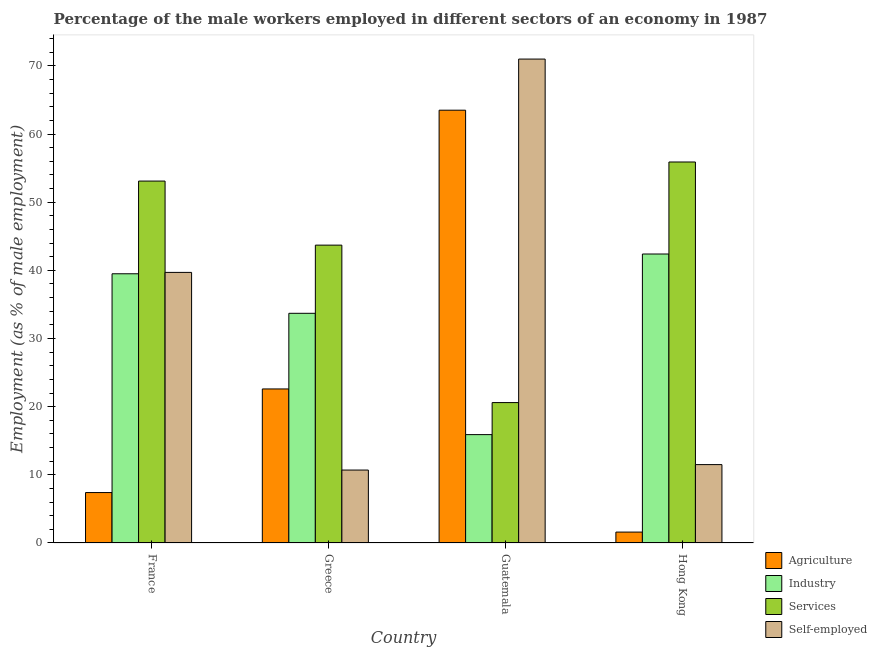How many different coloured bars are there?
Offer a very short reply. 4. Are the number of bars per tick equal to the number of legend labels?
Your answer should be compact. Yes. Are the number of bars on each tick of the X-axis equal?
Provide a short and direct response. Yes. How many bars are there on the 1st tick from the left?
Offer a very short reply. 4. What is the label of the 3rd group of bars from the left?
Offer a very short reply. Guatemala. What is the percentage of male workers in services in France?
Your response must be concise. 53.1. Across all countries, what is the maximum percentage of male workers in agriculture?
Your answer should be very brief. 63.5. Across all countries, what is the minimum percentage of self employed male workers?
Offer a very short reply. 10.7. In which country was the percentage of male workers in industry maximum?
Your answer should be compact. Hong Kong. In which country was the percentage of self employed male workers minimum?
Keep it short and to the point. Greece. What is the total percentage of male workers in industry in the graph?
Offer a very short reply. 131.5. What is the difference between the percentage of male workers in services in Guatemala and that in Hong Kong?
Offer a terse response. -35.3. What is the difference between the percentage of male workers in services in France and the percentage of male workers in industry in Guatemala?
Offer a very short reply. 37.2. What is the average percentage of male workers in agriculture per country?
Offer a very short reply. 23.78. What is the difference between the percentage of male workers in industry and percentage of male workers in services in Greece?
Provide a short and direct response. -10. In how many countries, is the percentage of male workers in industry greater than 30 %?
Your answer should be very brief. 3. What is the ratio of the percentage of male workers in services in Greece to that in Hong Kong?
Provide a succinct answer. 0.78. Is the difference between the percentage of male workers in agriculture in Greece and Guatemala greater than the difference between the percentage of male workers in industry in Greece and Guatemala?
Provide a short and direct response. No. What is the difference between the highest and the second highest percentage of male workers in industry?
Offer a terse response. 2.9. What is the difference between the highest and the lowest percentage of male workers in industry?
Provide a succinct answer. 26.5. Is it the case that in every country, the sum of the percentage of male workers in industry and percentage of male workers in services is greater than the sum of percentage of self employed male workers and percentage of male workers in agriculture?
Your response must be concise. No. What does the 1st bar from the left in Hong Kong represents?
Offer a very short reply. Agriculture. What does the 4th bar from the right in France represents?
Your answer should be compact. Agriculture. Is it the case that in every country, the sum of the percentage of male workers in agriculture and percentage of male workers in industry is greater than the percentage of male workers in services?
Your answer should be very brief. No. Are all the bars in the graph horizontal?
Provide a succinct answer. No. How many countries are there in the graph?
Your answer should be compact. 4. What is the difference between two consecutive major ticks on the Y-axis?
Your response must be concise. 10. Does the graph contain any zero values?
Give a very brief answer. No. How many legend labels are there?
Provide a short and direct response. 4. What is the title of the graph?
Offer a terse response. Percentage of the male workers employed in different sectors of an economy in 1987. Does "Denmark" appear as one of the legend labels in the graph?
Your answer should be compact. No. What is the label or title of the X-axis?
Your response must be concise. Country. What is the label or title of the Y-axis?
Keep it short and to the point. Employment (as % of male employment). What is the Employment (as % of male employment) in Agriculture in France?
Offer a very short reply. 7.4. What is the Employment (as % of male employment) in Industry in France?
Make the answer very short. 39.5. What is the Employment (as % of male employment) in Services in France?
Offer a very short reply. 53.1. What is the Employment (as % of male employment) of Self-employed in France?
Keep it short and to the point. 39.7. What is the Employment (as % of male employment) in Agriculture in Greece?
Keep it short and to the point. 22.6. What is the Employment (as % of male employment) in Industry in Greece?
Your answer should be very brief. 33.7. What is the Employment (as % of male employment) of Services in Greece?
Ensure brevity in your answer.  43.7. What is the Employment (as % of male employment) in Self-employed in Greece?
Provide a succinct answer. 10.7. What is the Employment (as % of male employment) of Agriculture in Guatemala?
Give a very brief answer. 63.5. What is the Employment (as % of male employment) in Industry in Guatemala?
Provide a short and direct response. 15.9. What is the Employment (as % of male employment) of Services in Guatemala?
Your answer should be compact. 20.6. What is the Employment (as % of male employment) of Self-employed in Guatemala?
Give a very brief answer. 71. What is the Employment (as % of male employment) of Agriculture in Hong Kong?
Offer a terse response. 1.6. What is the Employment (as % of male employment) in Industry in Hong Kong?
Provide a succinct answer. 42.4. What is the Employment (as % of male employment) in Services in Hong Kong?
Keep it short and to the point. 55.9. Across all countries, what is the maximum Employment (as % of male employment) of Agriculture?
Provide a succinct answer. 63.5. Across all countries, what is the maximum Employment (as % of male employment) of Industry?
Your response must be concise. 42.4. Across all countries, what is the maximum Employment (as % of male employment) of Services?
Provide a succinct answer. 55.9. Across all countries, what is the maximum Employment (as % of male employment) of Self-employed?
Your answer should be very brief. 71. Across all countries, what is the minimum Employment (as % of male employment) in Agriculture?
Your answer should be very brief. 1.6. Across all countries, what is the minimum Employment (as % of male employment) in Industry?
Your answer should be very brief. 15.9. Across all countries, what is the minimum Employment (as % of male employment) in Services?
Your response must be concise. 20.6. Across all countries, what is the minimum Employment (as % of male employment) in Self-employed?
Keep it short and to the point. 10.7. What is the total Employment (as % of male employment) in Agriculture in the graph?
Provide a short and direct response. 95.1. What is the total Employment (as % of male employment) in Industry in the graph?
Offer a terse response. 131.5. What is the total Employment (as % of male employment) of Services in the graph?
Give a very brief answer. 173.3. What is the total Employment (as % of male employment) in Self-employed in the graph?
Keep it short and to the point. 132.9. What is the difference between the Employment (as % of male employment) of Agriculture in France and that in Greece?
Keep it short and to the point. -15.2. What is the difference between the Employment (as % of male employment) in Industry in France and that in Greece?
Provide a short and direct response. 5.8. What is the difference between the Employment (as % of male employment) in Services in France and that in Greece?
Offer a terse response. 9.4. What is the difference between the Employment (as % of male employment) of Agriculture in France and that in Guatemala?
Your answer should be very brief. -56.1. What is the difference between the Employment (as % of male employment) in Industry in France and that in Guatemala?
Provide a succinct answer. 23.6. What is the difference between the Employment (as % of male employment) of Services in France and that in Guatemala?
Keep it short and to the point. 32.5. What is the difference between the Employment (as % of male employment) in Self-employed in France and that in Guatemala?
Provide a succinct answer. -31.3. What is the difference between the Employment (as % of male employment) of Industry in France and that in Hong Kong?
Give a very brief answer. -2.9. What is the difference between the Employment (as % of male employment) in Self-employed in France and that in Hong Kong?
Give a very brief answer. 28.2. What is the difference between the Employment (as % of male employment) in Agriculture in Greece and that in Guatemala?
Provide a succinct answer. -40.9. What is the difference between the Employment (as % of male employment) of Industry in Greece and that in Guatemala?
Your answer should be compact. 17.8. What is the difference between the Employment (as % of male employment) in Services in Greece and that in Guatemala?
Your response must be concise. 23.1. What is the difference between the Employment (as % of male employment) in Self-employed in Greece and that in Guatemala?
Ensure brevity in your answer.  -60.3. What is the difference between the Employment (as % of male employment) of Agriculture in Greece and that in Hong Kong?
Provide a succinct answer. 21. What is the difference between the Employment (as % of male employment) of Services in Greece and that in Hong Kong?
Provide a succinct answer. -12.2. What is the difference between the Employment (as % of male employment) in Agriculture in Guatemala and that in Hong Kong?
Offer a terse response. 61.9. What is the difference between the Employment (as % of male employment) of Industry in Guatemala and that in Hong Kong?
Offer a very short reply. -26.5. What is the difference between the Employment (as % of male employment) of Services in Guatemala and that in Hong Kong?
Your response must be concise. -35.3. What is the difference between the Employment (as % of male employment) of Self-employed in Guatemala and that in Hong Kong?
Make the answer very short. 59.5. What is the difference between the Employment (as % of male employment) of Agriculture in France and the Employment (as % of male employment) of Industry in Greece?
Make the answer very short. -26.3. What is the difference between the Employment (as % of male employment) of Agriculture in France and the Employment (as % of male employment) of Services in Greece?
Make the answer very short. -36.3. What is the difference between the Employment (as % of male employment) of Agriculture in France and the Employment (as % of male employment) of Self-employed in Greece?
Give a very brief answer. -3.3. What is the difference between the Employment (as % of male employment) in Industry in France and the Employment (as % of male employment) in Services in Greece?
Offer a very short reply. -4.2. What is the difference between the Employment (as % of male employment) in Industry in France and the Employment (as % of male employment) in Self-employed in Greece?
Your response must be concise. 28.8. What is the difference between the Employment (as % of male employment) of Services in France and the Employment (as % of male employment) of Self-employed in Greece?
Provide a succinct answer. 42.4. What is the difference between the Employment (as % of male employment) of Agriculture in France and the Employment (as % of male employment) of Industry in Guatemala?
Your response must be concise. -8.5. What is the difference between the Employment (as % of male employment) in Agriculture in France and the Employment (as % of male employment) in Services in Guatemala?
Your answer should be very brief. -13.2. What is the difference between the Employment (as % of male employment) of Agriculture in France and the Employment (as % of male employment) of Self-employed in Guatemala?
Offer a terse response. -63.6. What is the difference between the Employment (as % of male employment) in Industry in France and the Employment (as % of male employment) in Services in Guatemala?
Offer a very short reply. 18.9. What is the difference between the Employment (as % of male employment) in Industry in France and the Employment (as % of male employment) in Self-employed in Guatemala?
Offer a very short reply. -31.5. What is the difference between the Employment (as % of male employment) in Services in France and the Employment (as % of male employment) in Self-employed in Guatemala?
Ensure brevity in your answer.  -17.9. What is the difference between the Employment (as % of male employment) in Agriculture in France and the Employment (as % of male employment) in Industry in Hong Kong?
Provide a succinct answer. -35. What is the difference between the Employment (as % of male employment) of Agriculture in France and the Employment (as % of male employment) of Services in Hong Kong?
Provide a succinct answer. -48.5. What is the difference between the Employment (as % of male employment) of Industry in France and the Employment (as % of male employment) of Services in Hong Kong?
Your response must be concise. -16.4. What is the difference between the Employment (as % of male employment) in Services in France and the Employment (as % of male employment) in Self-employed in Hong Kong?
Make the answer very short. 41.6. What is the difference between the Employment (as % of male employment) of Agriculture in Greece and the Employment (as % of male employment) of Industry in Guatemala?
Your response must be concise. 6.7. What is the difference between the Employment (as % of male employment) in Agriculture in Greece and the Employment (as % of male employment) in Self-employed in Guatemala?
Make the answer very short. -48.4. What is the difference between the Employment (as % of male employment) in Industry in Greece and the Employment (as % of male employment) in Services in Guatemala?
Your answer should be compact. 13.1. What is the difference between the Employment (as % of male employment) in Industry in Greece and the Employment (as % of male employment) in Self-employed in Guatemala?
Provide a short and direct response. -37.3. What is the difference between the Employment (as % of male employment) of Services in Greece and the Employment (as % of male employment) of Self-employed in Guatemala?
Ensure brevity in your answer.  -27.3. What is the difference between the Employment (as % of male employment) of Agriculture in Greece and the Employment (as % of male employment) of Industry in Hong Kong?
Your response must be concise. -19.8. What is the difference between the Employment (as % of male employment) in Agriculture in Greece and the Employment (as % of male employment) in Services in Hong Kong?
Your answer should be compact. -33.3. What is the difference between the Employment (as % of male employment) of Industry in Greece and the Employment (as % of male employment) of Services in Hong Kong?
Ensure brevity in your answer.  -22.2. What is the difference between the Employment (as % of male employment) in Services in Greece and the Employment (as % of male employment) in Self-employed in Hong Kong?
Your response must be concise. 32.2. What is the difference between the Employment (as % of male employment) of Agriculture in Guatemala and the Employment (as % of male employment) of Industry in Hong Kong?
Provide a short and direct response. 21.1. What is the difference between the Employment (as % of male employment) of Services in Guatemala and the Employment (as % of male employment) of Self-employed in Hong Kong?
Your response must be concise. 9.1. What is the average Employment (as % of male employment) in Agriculture per country?
Make the answer very short. 23.77. What is the average Employment (as % of male employment) of Industry per country?
Keep it short and to the point. 32.88. What is the average Employment (as % of male employment) of Services per country?
Your answer should be very brief. 43.33. What is the average Employment (as % of male employment) in Self-employed per country?
Provide a short and direct response. 33.23. What is the difference between the Employment (as % of male employment) of Agriculture and Employment (as % of male employment) of Industry in France?
Your answer should be compact. -32.1. What is the difference between the Employment (as % of male employment) in Agriculture and Employment (as % of male employment) in Services in France?
Offer a very short reply. -45.7. What is the difference between the Employment (as % of male employment) of Agriculture and Employment (as % of male employment) of Self-employed in France?
Provide a succinct answer. -32.3. What is the difference between the Employment (as % of male employment) in Industry and Employment (as % of male employment) in Services in France?
Your answer should be very brief. -13.6. What is the difference between the Employment (as % of male employment) in Services and Employment (as % of male employment) in Self-employed in France?
Give a very brief answer. 13.4. What is the difference between the Employment (as % of male employment) of Agriculture and Employment (as % of male employment) of Services in Greece?
Your answer should be compact. -21.1. What is the difference between the Employment (as % of male employment) of Agriculture and Employment (as % of male employment) of Self-employed in Greece?
Offer a terse response. 11.9. What is the difference between the Employment (as % of male employment) of Services and Employment (as % of male employment) of Self-employed in Greece?
Provide a succinct answer. 33. What is the difference between the Employment (as % of male employment) of Agriculture and Employment (as % of male employment) of Industry in Guatemala?
Your answer should be very brief. 47.6. What is the difference between the Employment (as % of male employment) of Agriculture and Employment (as % of male employment) of Services in Guatemala?
Ensure brevity in your answer.  42.9. What is the difference between the Employment (as % of male employment) of Agriculture and Employment (as % of male employment) of Self-employed in Guatemala?
Provide a short and direct response. -7.5. What is the difference between the Employment (as % of male employment) in Industry and Employment (as % of male employment) in Self-employed in Guatemala?
Provide a short and direct response. -55.1. What is the difference between the Employment (as % of male employment) of Services and Employment (as % of male employment) of Self-employed in Guatemala?
Offer a terse response. -50.4. What is the difference between the Employment (as % of male employment) in Agriculture and Employment (as % of male employment) in Industry in Hong Kong?
Offer a very short reply. -40.8. What is the difference between the Employment (as % of male employment) in Agriculture and Employment (as % of male employment) in Services in Hong Kong?
Offer a very short reply. -54.3. What is the difference between the Employment (as % of male employment) in Industry and Employment (as % of male employment) in Services in Hong Kong?
Offer a very short reply. -13.5. What is the difference between the Employment (as % of male employment) of Industry and Employment (as % of male employment) of Self-employed in Hong Kong?
Ensure brevity in your answer.  30.9. What is the difference between the Employment (as % of male employment) in Services and Employment (as % of male employment) in Self-employed in Hong Kong?
Give a very brief answer. 44.4. What is the ratio of the Employment (as % of male employment) of Agriculture in France to that in Greece?
Provide a short and direct response. 0.33. What is the ratio of the Employment (as % of male employment) of Industry in France to that in Greece?
Give a very brief answer. 1.17. What is the ratio of the Employment (as % of male employment) in Services in France to that in Greece?
Offer a terse response. 1.22. What is the ratio of the Employment (as % of male employment) of Self-employed in France to that in Greece?
Offer a terse response. 3.71. What is the ratio of the Employment (as % of male employment) in Agriculture in France to that in Guatemala?
Provide a short and direct response. 0.12. What is the ratio of the Employment (as % of male employment) in Industry in France to that in Guatemala?
Your response must be concise. 2.48. What is the ratio of the Employment (as % of male employment) in Services in France to that in Guatemala?
Offer a terse response. 2.58. What is the ratio of the Employment (as % of male employment) of Self-employed in France to that in Guatemala?
Give a very brief answer. 0.56. What is the ratio of the Employment (as % of male employment) of Agriculture in France to that in Hong Kong?
Ensure brevity in your answer.  4.62. What is the ratio of the Employment (as % of male employment) of Industry in France to that in Hong Kong?
Your answer should be very brief. 0.93. What is the ratio of the Employment (as % of male employment) in Services in France to that in Hong Kong?
Offer a very short reply. 0.95. What is the ratio of the Employment (as % of male employment) of Self-employed in France to that in Hong Kong?
Your response must be concise. 3.45. What is the ratio of the Employment (as % of male employment) in Agriculture in Greece to that in Guatemala?
Your response must be concise. 0.36. What is the ratio of the Employment (as % of male employment) of Industry in Greece to that in Guatemala?
Your answer should be very brief. 2.12. What is the ratio of the Employment (as % of male employment) in Services in Greece to that in Guatemala?
Offer a terse response. 2.12. What is the ratio of the Employment (as % of male employment) in Self-employed in Greece to that in Guatemala?
Give a very brief answer. 0.15. What is the ratio of the Employment (as % of male employment) of Agriculture in Greece to that in Hong Kong?
Your response must be concise. 14.12. What is the ratio of the Employment (as % of male employment) in Industry in Greece to that in Hong Kong?
Your response must be concise. 0.79. What is the ratio of the Employment (as % of male employment) of Services in Greece to that in Hong Kong?
Provide a short and direct response. 0.78. What is the ratio of the Employment (as % of male employment) in Self-employed in Greece to that in Hong Kong?
Keep it short and to the point. 0.93. What is the ratio of the Employment (as % of male employment) of Agriculture in Guatemala to that in Hong Kong?
Offer a terse response. 39.69. What is the ratio of the Employment (as % of male employment) in Services in Guatemala to that in Hong Kong?
Offer a very short reply. 0.37. What is the ratio of the Employment (as % of male employment) of Self-employed in Guatemala to that in Hong Kong?
Offer a very short reply. 6.17. What is the difference between the highest and the second highest Employment (as % of male employment) of Agriculture?
Offer a terse response. 40.9. What is the difference between the highest and the second highest Employment (as % of male employment) of Industry?
Keep it short and to the point. 2.9. What is the difference between the highest and the second highest Employment (as % of male employment) in Self-employed?
Give a very brief answer. 31.3. What is the difference between the highest and the lowest Employment (as % of male employment) of Agriculture?
Your answer should be very brief. 61.9. What is the difference between the highest and the lowest Employment (as % of male employment) of Services?
Give a very brief answer. 35.3. What is the difference between the highest and the lowest Employment (as % of male employment) in Self-employed?
Provide a succinct answer. 60.3. 